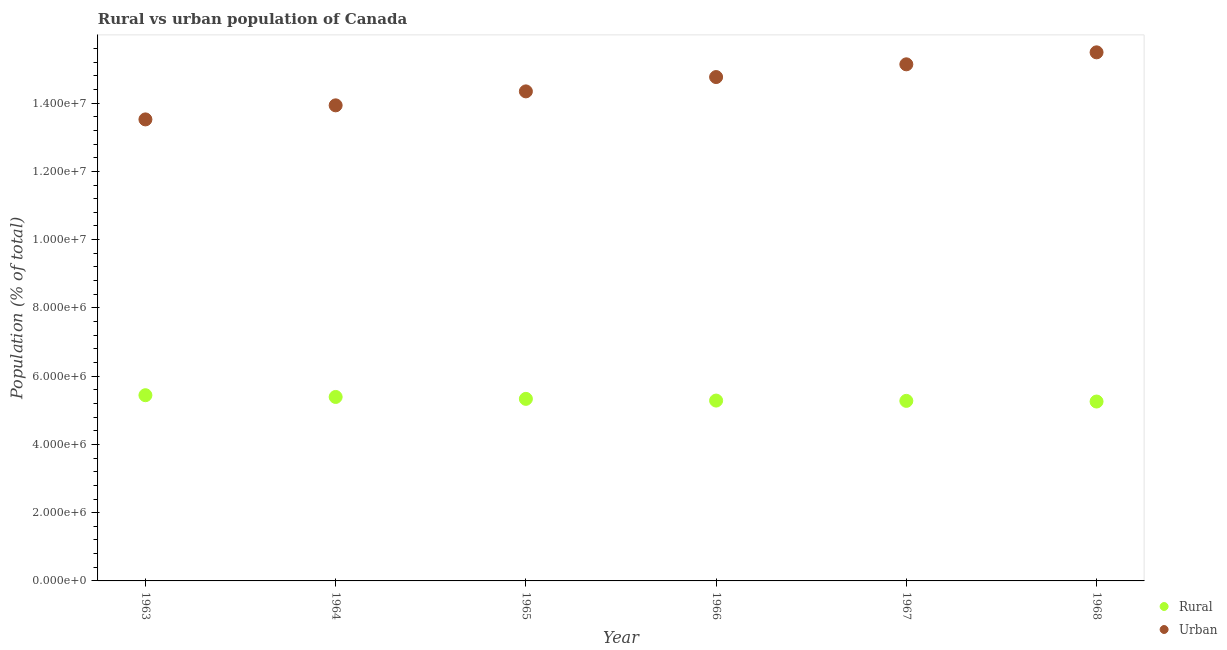What is the rural population density in 1968?
Offer a terse response. 5.26e+06. Across all years, what is the maximum rural population density?
Ensure brevity in your answer.  5.44e+06. Across all years, what is the minimum rural population density?
Provide a succinct answer. 5.26e+06. In which year was the urban population density maximum?
Offer a terse response. 1968. What is the total rural population density in the graph?
Provide a short and direct response. 3.20e+07. What is the difference between the urban population density in 1964 and that in 1965?
Your response must be concise. -4.09e+05. What is the difference between the urban population density in 1963 and the rural population density in 1965?
Make the answer very short. 8.19e+06. What is the average rural population density per year?
Provide a succinct answer. 5.33e+06. In the year 1963, what is the difference between the urban population density and rural population density?
Provide a short and direct response. 8.08e+06. In how many years, is the urban population density greater than 10400000 %?
Make the answer very short. 6. What is the ratio of the urban population density in 1964 to that in 1967?
Give a very brief answer. 0.92. Is the difference between the urban population density in 1967 and 1968 greater than the difference between the rural population density in 1967 and 1968?
Make the answer very short. No. What is the difference between the highest and the second highest rural population density?
Keep it short and to the point. 5.10e+04. What is the difference between the highest and the lowest urban population density?
Your response must be concise. 1.97e+06. In how many years, is the rural population density greater than the average rural population density taken over all years?
Provide a short and direct response. 3. Is the sum of the urban population density in 1963 and 1964 greater than the maximum rural population density across all years?
Provide a short and direct response. Yes. Is the rural population density strictly greater than the urban population density over the years?
Your response must be concise. No. How many dotlines are there?
Keep it short and to the point. 2. What is the difference between two consecutive major ticks on the Y-axis?
Your response must be concise. 2.00e+06. Are the values on the major ticks of Y-axis written in scientific E-notation?
Your answer should be compact. Yes. Does the graph contain any zero values?
Provide a succinct answer. No. Does the graph contain grids?
Provide a succinct answer. No. How many legend labels are there?
Give a very brief answer. 2. What is the title of the graph?
Keep it short and to the point. Rural vs urban population of Canada. Does "Highest 10% of population" appear as one of the legend labels in the graph?
Your answer should be compact. No. What is the label or title of the Y-axis?
Offer a very short reply. Population (% of total). What is the Population (% of total) of Rural in 1963?
Your response must be concise. 5.44e+06. What is the Population (% of total) in Urban in 1963?
Keep it short and to the point. 1.35e+07. What is the Population (% of total) in Rural in 1964?
Make the answer very short. 5.39e+06. What is the Population (% of total) of Urban in 1964?
Ensure brevity in your answer.  1.39e+07. What is the Population (% of total) in Rural in 1965?
Your response must be concise. 5.33e+06. What is the Population (% of total) in Urban in 1965?
Your answer should be compact. 1.43e+07. What is the Population (% of total) of Rural in 1966?
Give a very brief answer. 5.28e+06. What is the Population (% of total) of Urban in 1966?
Offer a terse response. 1.48e+07. What is the Population (% of total) in Rural in 1967?
Your answer should be very brief. 5.28e+06. What is the Population (% of total) in Urban in 1967?
Your answer should be very brief. 1.51e+07. What is the Population (% of total) in Rural in 1968?
Your answer should be compact. 5.26e+06. What is the Population (% of total) in Urban in 1968?
Your answer should be very brief. 1.55e+07. Across all years, what is the maximum Population (% of total) of Rural?
Offer a very short reply. 5.44e+06. Across all years, what is the maximum Population (% of total) in Urban?
Ensure brevity in your answer.  1.55e+07. Across all years, what is the minimum Population (% of total) of Rural?
Your answer should be compact. 5.26e+06. Across all years, what is the minimum Population (% of total) of Urban?
Give a very brief answer. 1.35e+07. What is the total Population (% of total) in Rural in the graph?
Offer a terse response. 3.20e+07. What is the total Population (% of total) of Urban in the graph?
Give a very brief answer. 8.72e+07. What is the difference between the Population (% of total) of Rural in 1963 and that in 1964?
Offer a very short reply. 5.10e+04. What is the difference between the Population (% of total) in Urban in 1963 and that in 1964?
Offer a very short reply. -4.12e+05. What is the difference between the Population (% of total) in Rural in 1963 and that in 1965?
Your response must be concise. 1.07e+05. What is the difference between the Population (% of total) in Urban in 1963 and that in 1965?
Give a very brief answer. -8.21e+05. What is the difference between the Population (% of total) in Rural in 1963 and that in 1966?
Make the answer very short. 1.57e+05. What is the difference between the Population (% of total) of Urban in 1963 and that in 1966?
Provide a short and direct response. -1.24e+06. What is the difference between the Population (% of total) in Rural in 1963 and that in 1967?
Keep it short and to the point. 1.66e+05. What is the difference between the Population (% of total) of Urban in 1963 and that in 1967?
Offer a terse response. -1.61e+06. What is the difference between the Population (% of total) of Rural in 1963 and that in 1968?
Your answer should be compact. 1.85e+05. What is the difference between the Population (% of total) of Urban in 1963 and that in 1968?
Keep it short and to the point. -1.97e+06. What is the difference between the Population (% of total) of Rural in 1964 and that in 1965?
Make the answer very short. 5.60e+04. What is the difference between the Population (% of total) in Urban in 1964 and that in 1965?
Your answer should be compact. -4.09e+05. What is the difference between the Population (% of total) of Rural in 1964 and that in 1966?
Give a very brief answer. 1.06e+05. What is the difference between the Population (% of total) in Urban in 1964 and that in 1966?
Your answer should be compact. -8.29e+05. What is the difference between the Population (% of total) in Rural in 1964 and that in 1967?
Your answer should be compact. 1.15e+05. What is the difference between the Population (% of total) of Urban in 1964 and that in 1967?
Make the answer very short. -1.20e+06. What is the difference between the Population (% of total) of Rural in 1964 and that in 1968?
Your answer should be very brief. 1.34e+05. What is the difference between the Population (% of total) of Urban in 1964 and that in 1968?
Your response must be concise. -1.55e+06. What is the difference between the Population (% of total) of Rural in 1965 and that in 1966?
Your answer should be compact. 5.01e+04. What is the difference between the Population (% of total) in Urban in 1965 and that in 1966?
Provide a succinct answer. -4.20e+05. What is the difference between the Population (% of total) of Rural in 1965 and that in 1967?
Offer a very short reply. 5.88e+04. What is the difference between the Population (% of total) of Urban in 1965 and that in 1967?
Keep it short and to the point. -7.93e+05. What is the difference between the Population (% of total) in Rural in 1965 and that in 1968?
Your answer should be very brief. 7.82e+04. What is the difference between the Population (% of total) of Urban in 1965 and that in 1968?
Offer a terse response. -1.14e+06. What is the difference between the Population (% of total) of Rural in 1966 and that in 1967?
Provide a succinct answer. 8771. What is the difference between the Population (% of total) in Urban in 1966 and that in 1967?
Keep it short and to the point. -3.73e+05. What is the difference between the Population (% of total) in Rural in 1966 and that in 1968?
Offer a very short reply. 2.81e+04. What is the difference between the Population (% of total) in Urban in 1966 and that in 1968?
Your answer should be very brief. -7.24e+05. What is the difference between the Population (% of total) in Rural in 1967 and that in 1968?
Offer a very short reply. 1.94e+04. What is the difference between the Population (% of total) in Urban in 1967 and that in 1968?
Your response must be concise. -3.51e+05. What is the difference between the Population (% of total) in Rural in 1963 and the Population (% of total) in Urban in 1964?
Offer a very short reply. -8.49e+06. What is the difference between the Population (% of total) of Rural in 1963 and the Population (% of total) of Urban in 1965?
Your answer should be compact. -8.90e+06. What is the difference between the Population (% of total) of Rural in 1963 and the Population (% of total) of Urban in 1966?
Your answer should be compact. -9.32e+06. What is the difference between the Population (% of total) in Rural in 1963 and the Population (% of total) in Urban in 1967?
Keep it short and to the point. -9.70e+06. What is the difference between the Population (% of total) of Rural in 1963 and the Population (% of total) of Urban in 1968?
Provide a succinct answer. -1.00e+07. What is the difference between the Population (% of total) in Rural in 1964 and the Population (% of total) in Urban in 1965?
Your answer should be compact. -8.95e+06. What is the difference between the Population (% of total) of Rural in 1964 and the Population (% of total) of Urban in 1966?
Ensure brevity in your answer.  -9.37e+06. What is the difference between the Population (% of total) of Rural in 1964 and the Population (% of total) of Urban in 1967?
Provide a short and direct response. -9.75e+06. What is the difference between the Population (% of total) in Rural in 1964 and the Population (% of total) in Urban in 1968?
Provide a short and direct response. -1.01e+07. What is the difference between the Population (% of total) in Rural in 1965 and the Population (% of total) in Urban in 1966?
Provide a short and direct response. -9.43e+06. What is the difference between the Population (% of total) in Rural in 1965 and the Population (% of total) in Urban in 1967?
Your response must be concise. -9.80e+06. What is the difference between the Population (% of total) in Rural in 1965 and the Population (% of total) in Urban in 1968?
Provide a succinct answer. -1.02e+07. What is the difference between the Population (% of total) of Rural in 1966 and the Population (% of total) of Urban in 1967?
Your response must be concise. -9.85e+06. What is the difference between the Population (% of total) in Rural in 1966 and the Population (% of total) in Urban in 1968?
Make the answer very short. -1.02e+07. What is the difference between the Population (% of total) in Rural in 1967 and the Population (% of total) in Urban in 1968?
Give a very brief answer. -1.02e+07. What is the average Population (% of total) of Rural per year?
Your answer should be compact. 5.33e+06. What is the average Population (% of total) in Urban per year?
Your answer should be very brief. 1.45e+07. In the year 1963, what is the difference between the Population (% of total) of Rural and Population (% of total) of Urban?
Your answer should be very brief. -8.08e+06. In the year 1964, what is the difference between the Population (% of total) of Rural and Population (% of total) of Urban?
Keep it short and to the point. -8.54e+06. In the year 1965, what is the difference between the Population (% of total) of Rural and Population (% of total) of Urban?
Offer a terse response. -9.01e+06. In the year 1966, what is the difference between the Population (% of total) of Rural and Population (% of total) of Urban?
Make the answer very short. -9.48e+06. In the year 1967, what is the difference between the Population (% of total) of Rural and Population (% of total) of Urban?
Your answer should be very brief. -9.86e+06. In the year 1968, what is the difference between the Population (% of total) in Rural and Population (% of total) in Urban?
Provide a succinct answer. -1.02e+07. What is the ratio of the Population (% of total) in Rural in 1963 to that in 1964?
Your response must be concise. 1.01. What is the ratio of the Population (% of total) of Urban in 1963 to that in 1964?
Make the answer very short. 0.97. What is the ratio of the Population (% of total) of Rural in 1963 to that in 1965?
Offer a terse response. 1.02. What is the ratio of the Population (% of total) in Urban in 1963 to that in 1965?
Ensure brevity in your answer.  0.94. What is the ratio of the Population (% of total) in Rural in 1963 to that in 1966?
Your answer should be compact. 1.03. What is the ratio of the Population (% of total) in Urban in 1963 to that in 1966?
Give a very brief answer. 0.92. What is the ratio of the Population (% of total) of Rural in 1963 to that in 1967?
Offer a very short reply. 1.03. What is the ratio of the Population (% of total) in Urban in 1963 to that in 1967?
Your answer should be very brief. 0.89. What is the ratio of the Population (% of total) in Rural in 1963 to that in 1968?
Give a very brief answer. 1.04. What is the ratio of the Population (% of total) of Urban in 1963 to that in 1968?
Provide a succinct answer. 0.87. What is the ratio of the Population (% of total) in Rural in 1964 to that in 1965?
Your answer should be compact. 1.01. What is the ratio of the Population (% of total) in Urban in 1964 to that in 1965?
Provide a succinct answer. 0.97. What is the ratio of the Population (% of total) of Rural in 1964 to that in 1966?
Make the answer very short. 1.02. What is the ratio of the Population (% of total) in Urban in 1964 to that in 1966?
Keep it short and to the point. 0.94. What is the ratio of the Population (% of total) in Rural in 1964 to that in 1967?
Provide a short and direct response. 1.02. What is the ratio of the Population (% of total) in Urban in 1964 to that in 1967?
Keep it short and to the point. 0.92. What is the ratio of the Population (% of total) of Rural in 1964 to that in 1968?
Provide a succinct answer. 1.03. What is the ratio of the Population (% of total) of Urban in 1964 to that in 1968?
Your answer should be compact. 0.9. What is the ratio of the Population (% of total) of Rural in 1965 to that in 1966?
Keep it short and to the point. 1.01. What is the ratio of the Population (% of total) of Urban in 1965 to that in 1966?
Your response must be concise. 0.97. What is the ratio of the Population (% of total) of Rural in 1965 to that in 1967?
Provide a succinct answer. 1.01. What is the ratio of the Population (% of total) of Urban in 1965 to that in 1967?
Your response must be concise. 0.95. What is the ratio of the Population (% of total) of Rural in 1965 to that in 1968?
Provide a short and direct response. 1.01. What is the ratio of the Population (% of total) in Urban in 1965 to that in 1968?
Provide a short and direct response. 0.93. What is the ratio of the Population (% of total) in Urban in 1966 to that in 1967?
Provide a succinct answer. 0.98. What is the ratio of the Population (% of total) in Rural in 1966 to that in 1968?
Offer a very short reply. 1.01. What is the ratio of the Population (% of total) of Urban in 1966 to that in 1968?
Your answer should be compact. 0.95. What is the ratio of the Population (% of total) of Urban in 1967 to that in 1968?
Give a very brief answer. 0.98. What is the difference between the highest and the second highest Population (% of total) in Rural?
Offer a very short reply. 5.10e+04. What is the difference between the highest and the second highest Population (% of total) in Urban?
Ensure brevity in your answer.  3.51e+05. What is the difference between the highest and the lowest Population (% of total) of Rural?
Your answer should be very brief. 1.85e+05. What is the difference between the highest and the lowest Population (% of total) in Urban?
Provide a succinct answer. 1.97e+06. 